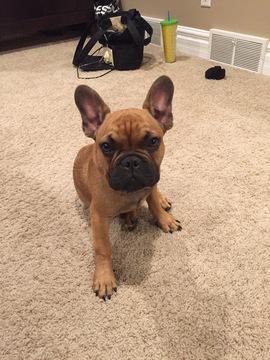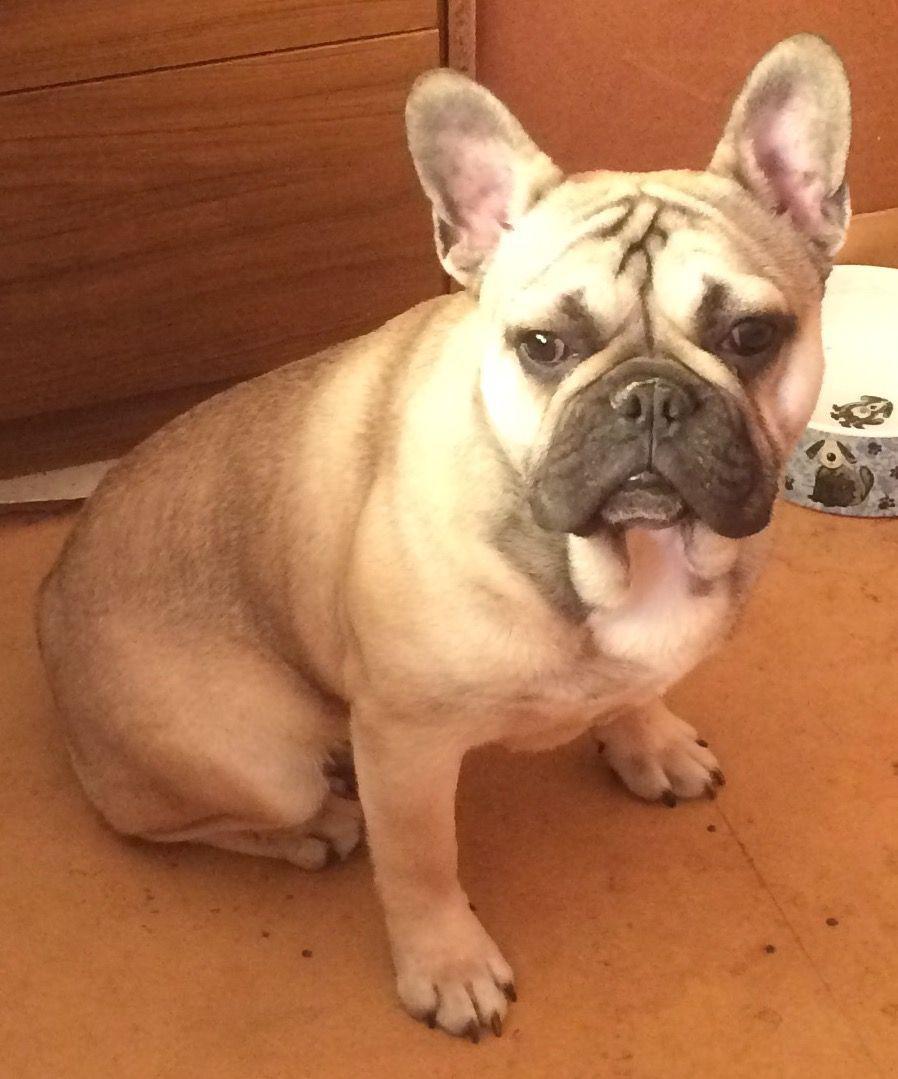The first image is the image on the left, the second image is the image on the right. Analyze the images presented: Is the assertion "There are at least three dogs." valid? Answer yes or no. No. The first image is the image on the left, the second image is the image on the right. Given the left and right images, does the statement "One image contains a single light-colored dog, and the other includes a black dog standing on all fours." hold true? Answer yes or no. No. 